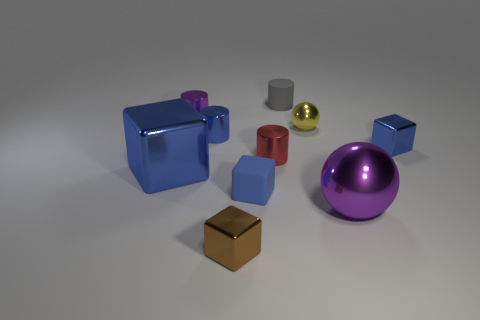Are there any other things that have the same material as the small brown object?
Make the answer very short. Yes. The shiny cylinder that is the same color as the large block is what size?
Give a very brief answer. Small. Are there any big metallic balls of the same color as the rubber cube?
Ensure brevity in your answer.  No. There is a ball that is the same size as the purple metallic cylinder; what is its color?
Ensure brevity in your answer.  Yellow. What number of brown metallic objects are in front of the cylinder that is behind the purple metallic cylinder?
Your answer should be compact. 1. What number of things are tiny matte things in front of the small sphere or tiny metallic blocks?
Ensure brevity in your answer.  3. How many small cylinders have the same material as the brown block?
Your answer should be compact. 3. The tiny thing that is the same color as the large shiny sphere is what shape?
Offer a very short reply. Cylinder. Is the number of small brown metallic blocks that are on the right side of the yellow sphere the same as the number of blue things?
Provide a succinct answer. No. What size is the shiny cylinder that is on the right side of the brown metallic object?
Your answer should be very brief. Small. 